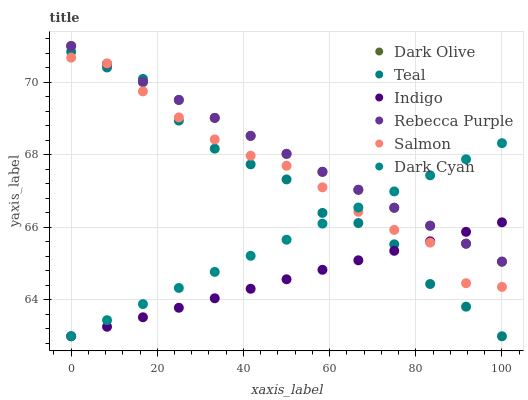Does Indigo have the minimum area under the curve?
Answer yes or no. Yes. Does Rebecca Purple have the maximum area under the curve?
Answer yes or no. Yes. Does Dark Olive have the minimum area under the curve?
Answer yes or no. No. Does Dark Olive have the maximum area under the curve?
Answer yes or no. No. Is Rebecca Purple the smoothest?
Answer yes or no. Yes. Is Teal the roughest?
Answer yes or no. Yes. Is Dark Olive the smoothest?
Answer yes or no. No. Is Dark Olive the roughest?
Answer yes or no. No. Does Indigo have the lowest value?
Answer yes or no. Yes. Does Dark Olive have the lowest value?
Answer yes or no. No. Does Rebecca Purple have the highest value?
Answer yes or no. Yes. Does Salmon have the highest value?
Answer yes or no. No. Does Teal intersect Dark Olive?
Answer yes or no. Yes. Is Teal less than Dark Olive?
Answer yes or no. No. Is Teal greater than Dark Olive?
Answer yes or no. No. 